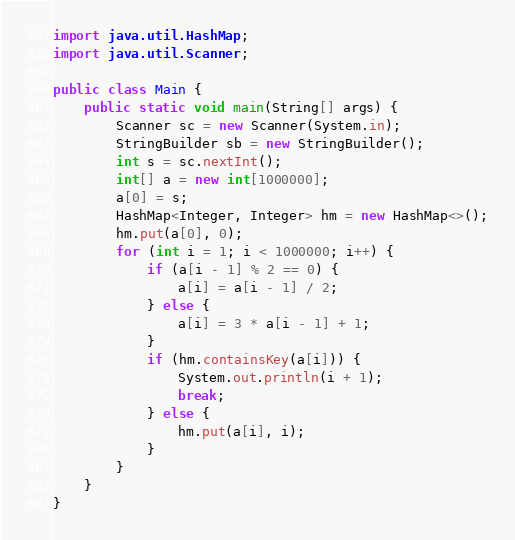<code> <loc_0><loc_0><loc_500><loc_500><_Java_>import java.util.HashMap;
import java.util.Scanner;

public class Main {
	public static void main(String[] args) {
		Scanner sc = new Scanner(System.in);
		StringBuilder sb = new StringBuilder();
		int s = sc.nextInt();
		int[] a = new int[1000000];
		a[0] = s;
		HashMap<Integer, Integer> hm = new HashMap<>();
		hm.put(a[0], 0);
		for (int i = 1; i < 1000000; i++) {
			if (a[i - 1] % 2 == 0) {
				a[i] = a[i - 1] / 2;
			} else {
				a[i] = 3 * a[i - 1] + 1;
			}
			if (hm.containsKey(a[i])) {
				System.out.println(i + 1);
				break;
			} else {
				hm.put(a[i], i);
			}
		}
	}
}
</code> 